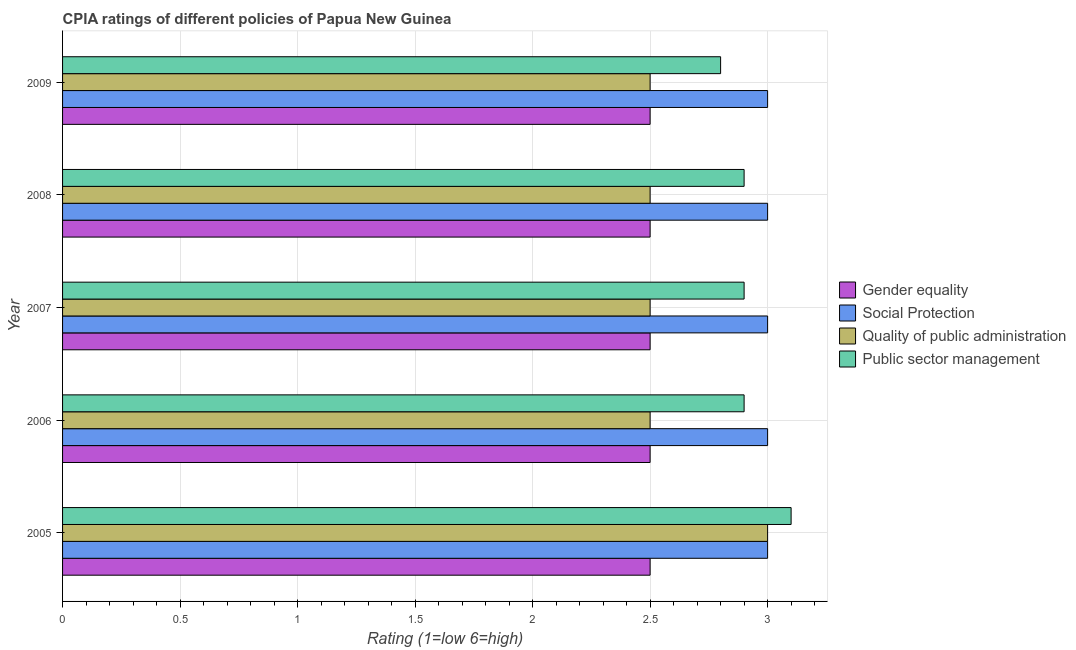How many different coloured bars are there?
Make the answer very short. 4. How many groups of bars are there?
Your response must be concise. 5. How many bars are there on the 1st tick from the bottom?
Keep it short and to the point. 4. What is the cpia rating of gender equality in 2008?
Offer a terse response. 2.5. Across all years, what is the maximum cpia rating of gender equality?
Ensure brevity in your answer.  2.5. Across all years, what is the minimum cpia rating of public sector management?
Your answer should be very brief. 2.8. In which year was the cpia rating of public sector management maximum?
Provide a succinct answer. 2005. What is the total cpia rating of public sector management in the graph?
Offer a very short reply. 14.6. What is the difference between the cpia rating of public sector management in 2007 and the cpia rating of quality of public administration in 2006?
Give a very brief answer. 0.4. What is the ratio of the cpia rating of public sector management in 2005 to that in 2008?
Your response must be concise. 1.07. What is the difference between the highest and the lowest cpia rating of social protection?
Keep it short and to the point. 0. What does the 3rd bar from the top in 2005 represents?
Give a very brief answer. Social Protection. What does the 3rd bar from the bottom in 2007 represents?
Ensure brevity in your answer.  Quality of public administration. Is it the case that in every year, the sum of the cpia rating of gender equality and cpia rating of social protection is greater than the cpia rating of quality of public administration?
Ensure brevity in your answer.  Yes. Are all the bars in the graph horizontal?
Offer a very short reply. Yes. How many years are there in the graph?
Offer a terse response. 5. What is the difference between two consecutive major ticks on the X-axis?
Provide a succinct answer. 0.5. Does the graph contain grids?
Give a very brief answer. Yes. How many legend labels are there?
Ensure brevity in your answer.  4. What is the title of the graph?
Your response must be concise. CPIA ratings of different policies of Papua New Guinea. Does "Social Awareness" appear as one of the legend labels in the graph?
Your response must be concise. No. What is the label or title of the Y-axis?
Your answer should be very brief. Year. What is the Rating (1=low 6=high) in Gender equality in 2005?
Make the answer very short. 2.5. What is the Rating (1=low 6=high) of Social Protection in 2005?
Your response must be concise. 3. What is the Rating (1=low 6=high) of Quality of public administration in 2005?
Keep it short and to the point. 3. What is the Rating (1=low 6=high) of Public sector management in 2005?
Offer a terse response. 3.1. What is the Rating (1=low 6=high) in Social Protection in 2006?
Your answer should be very brief. 3. What is the Rating (1=low 6=high) of Public sector management in 2006?
Offer a terse response. 2.9. What is the Rating (1=low 6=high) of Public sector management in 2007?
Offer a very short reply. 2.9. What is the Rating (1=low 6=high) in Gender equality in 2008?
Provide a succinct answer. 2.5. What is the Rating (1=low 6=high) in Social Protection in 2008?
Make the answer very short. 3. What is the Rating (1=low 6=high) of Gender equality in 2009?
Your response must be concise. 2.5. What is the Rating (1=low 6=high) of Public sector management in 2009?
Provide a short and direct response. 2.8. Across all years, what is the maximum Rating (1=low 6=high) in Public sector management?
Your answer should be compact. 3.1. Across all years, what is the minimum Rating (1=low 6=high) in Gender equality?
Provide a succinct answer. 2.5. Across all years, what is the minimum Rating (1=low 6=high) of Social Protection?
Your response must be concise. 3. What is the total Rating (1=low 6=high) of Gender equality in the graph?
Make the answer very short. 12.5. What is the total Rating (1=low 6=high) of Quality of public administration in the graph?
Give a very brief answer. 13. What is the difference between the Rating (1=low 6=high) in Social Protection in 2005 and that in 2006?
Provide a short and direct response. 0. What is the difference between the Rating (1=low 6=high) in Quality of public administration in 2005 and that in 2006?
Your answer should be very brief. 0.5. What is the difference between the Rating (1=low 6=high) of Public sector management in 2005 and that in 2006?
Ensure brevity in your answer.  0.2. What is the difference between the Rating (1=low 6=high) in Social Protection in 2005 and that in 2007?
Your answer should be compact. 0. What is the difference between the Rating (1=low 6=high) in Quality of public administration in 2005 and that in 2007?
Your answer should be compact. 0.5. What is the difference between the Rating (1=low 6=high) of Social Protection in 2005 and that in 2008?
Provide a short and direct response. 0. What is the difference between the Rating (1=low 6=high) of Quality of public administration in 2005 and that in 2008?
Give a very brief answer. 0.5. What is the difference between the Rating (1=low 6=high) in Public sector management in 2005 and that in 2008?
Your answer should be very brief. 0.2. What is the difference between the Rating (1=low 6=high) in Gender equality in 2005 and that in 2009?
Offer a terse response. 0. What is the difference between the Rating (1=low 6=high) in Social Protection in 2005 and that in 2009?
Your answer should be compact. 0. What is the difference between the Rating (1=low 6=high) in Quality of public administration in 2005 and that in 2009?
Provide a short and direct response. 0.5. What is the difference between the Rating (1=low 6=high) in Quality of public administration in 2006 and that in 2008?
Give a very brief answer. 0. What is the difference between the Rating (1=low 6=high) of Gender equality in 2006 and that in 2009?
Your answer should be compact. 0. What is the difference between the Rating (1=low 6=high) in Social Protection in 2006 and that in 2009?
Keep it short and to the point. 0. What is the difference between the Rating (1=low 6=high) of Gender equality in 2007 and that in 2008?
Your answer should be compact. 0. What is the difference between the Rating (1=low 6=high) in Quality of public administration in 2007 and that in 2008?
Offer a terse response. 0. What is the difference between the Rating (1=low 6=high) of Quality of public administration in 2007 and that in 2009?
Your response must be concise. 0. What is the difference between the Rating (1=low 6=high) in Public sector management in 2007 and that in 2009?
Your answer should be very brief. 0.1. What is the difference between the Rating (1=low 6=high) of Quality of public administration in 2008 and that in 2009?
Your answer should be compact. 0. What is the difference between the Rating (1=low 6=high) in Public sector management in 2008 and that in 2009?
Offer a terse response. 0.1. What is the difference between the Rating (1=low 6=high) in Social Protection in 2005 and the Rating (1=low 6=high) in Quality of public administration in 2006?
Offer a very short reply. 0.5. What is the difference between the Rating (1=low 6=high) of Social Protection in 2005 and the Rating (1=low 6=high) of Public sector management in 2006?
Your answer should be compact. 0.1. What is the difference between the Rating (1=low 6=high) in Quality of public administration in 2005 and the Rating (1=low 6=high) in Public sector management in 2006?
Provide a short and direct response. 0.1. What is the difference between the Rating (1=low 6=high) in Gender equality in 2005 and the Rating (1=low 6=high) in Social Protection in 2007?
Give a very brief answer. -0.5. What is the difference between the Rating (1=low 6=high) in Gender equality in 2005 and the Rating (1=low 6=high) in Social Protection in 2008?
Give a very brief answer. -0.5. What is the difference between the Rating (1=low 6=high) of Gender equality in 2005 and the Rating (1=low 6=high) of Quality of public administration in 2008?
Give a very brief answer. 0. What is the difference between the Rating (1=low 6=high) in Gender equality in 2005 and the Rating (1=low 6=high) in Public sector management in 2008?
Keep it short and to the point. -0.4. What is the difference between the Rating (1=low 6=high) of Social Protection in 2005 and the Rating (1=low 6=high) of Public sector management in 2009?
Your answer should be very brief. 0.2. What is the difference between the Rating (1=low 6=high) of Social Protection in 2006 and the Rating (1=low 6=high) of Quality of public administration in 2007?
Make the answer very short. 0.5. What is the difference between the Rating (1=low 6=high) of Quality of public administration in 2006 and the Rating (1=low 6=high) of Public sector management in 2007?
Your response must be concise. -0.4. What is the difference between the Rating (1=low 6=high) of Gender equality in 2006 and the Rating (1=low 6=high) of Social Protection in 2008?
Make the answer very short. -0.5. What is the difference between the Rating (1=low 6=high) in Social Protection in 2006 and the Rating (1=low 6=high) in Public sector management in 2008?
Give a very brief answer. 0.1. What is the difference between the Rating (1=low 6=high) of Quality of public administration in 2006 and the Rating (1=low 6=high) of Public sector management in 2008?
Your answer should be very brief. -0.4. What is the difference between the Rating (1=low 6=high) in Gender equality in 2006 and the Rating (1=low 6=high) in Quality of public administration in 2009?
Ensure brevity in your answer.  0. What is the difference between the Rating (1=low 6=high) in Gender equality in 2007 and the Rating (1=low 6=high) in Social Protection in 2008?
Ensure brevity in your answer.  -0.5. What is the difference between the Rating (1=low 6=high) in Gender equality in 2007 and the Rating (1=low 6=high) in Public sector management in 2008?
Offer a terse response. -0.4. What is the difference between the Rating (1=low 6=high) of Social Protection in 2007 and the Rating (1=low 6=high) of Quality of public administration in 2008?
Your answer should be very brief. 0.5. What is the difference between the Rating (1=low 6=high) in Social Protection in 2007 and the Rating (1=low 6=high) in Public sector management in 2008?
Your answer should be very brief. 0.1. What is the difference between the Rating (1=low 6=high) in Quality of public administration in 2007 and the Rating (1=low 6=high) in Public sector management in 2008?
Ensure brevity in your answer.  -0.4. What is the difference between the Rating (1=low 6=high) in Gender equality in 2007 and the Rating (1=low 6=high) in Public sector management in 2009?
Ensure brevity in your answer.  -0.3. What is the difference between the Rating (1=low 6=high) of Social Protection in 2007 and the Rating (1=low 6=high) of Quality of public administration in 2009?
Your response must be concise. 0.5. What is the difference between the Rating (1=low 6=high) in Social Protection in 2007 and the Rating (1=low 6=high) in Public sector management in 2009?
Your answer should be very brief. 0.2. What is the difference between the Rating (1=low 6=high) of Gender equality in 2008 and the Rating (1=low 6=high) of Public sector management in 2009?
Provide a short and direct response. -0.3. What is the difference between the Rating (1=low 6=high) of Quality of public administration in 2008 and the Rating (1=low 6=high) of Public sector management in 2009?
Keep it short and to the point. -0.3. What is the average Rating (1=low 6=high) of Quality of public administration per year?
Provide a short and direct response. 2.6. What is the average Rating (1=low 6=high) in Public sector management per year?
Ensure brevity in your answer.  2.92. In the year 2005, what is the difference between the Rating (1=low 6=high) in Social Protection and Rating (1=low 6=high) in Public sector management?
Offer a terse response. -0.1. In the year 2005, what is the difference between the Rating (1=low 6=high) of Quality of public administration and Rating (1=low 6=high) of Public sector management?
Provide a short and direct response. -0.1. In the year 2006, what is the difference between the Rating (1=low 6=high) in Gender equality and Rating (1=low 6=high) in Public sector management?
Your response must be concise. -0.4. In the year 2006, what is the difference between the Rating (1=low 6=high) in Social Protection and Rating (1=low 6=high) in Quality of public administration?
Give a very brief answer. 0.5. In the year 2007, what is the difference between the Rating (1=low 6=high) of Social Protection and Rating (1=low 6=high) of Public sector management?
Offer a very short reply. 0.1. In the year 2007, what is the difference between the Rating (1=low 6=high) of Quality of public administration and Rating (1=low 6=high) of Public sector management?
Offer a terse response. -0.4. In the year 2008, what is the difference between the Rating (1=low 6=high) of Gender equality and Rating (1=low 6=high) of Public sector management?
Your answer should be very brief. -0.4. In the year 2008, what is the difference between the Rating (1=low 6=high) in Social Protection and Rating (1=low 6=high) in Quality of public administration?
Make the answer very short. 0.5. In the year 2008, what is the difference between the Rating (1=low 6=high) in Social Protection and Rating (1=low 6=high) in Public sector management?
Give a very brief answer. 0.1. In the year 2009, what is the difference between the Rating (1=low 6=high) of Gender equality and Rating (1=low 6=high) of Social Protection?
Give a very brief answer. -0.5. In the year 2009, what is the difference between the Rating (1=low 6=high) of Gender equality and Rating (1=low 6=high) of Public sector management?
Give a very brief answer. -0.3. In the year 2009, what is the difference between the Rating (1=low 6=high) in Social Protection and Rating (1=low 6=high) in Quality of public administration?
Give a very brief answer. 0.5. In the year 2009, what is the difference between the Rating (1=low 6=high) in Social Protection and Rating (1=low 6=high) in Public sector management?
Offer a terse response. 0.2. In the year 2009, what is the difference between the Rating (1=low 6=high) of Quality of public administration and Rating (1=low 6=high) of Public sector management?
Offer a terse response. -0.3. What is the ratio of the Rating (1=low 6=high) in Public sector management in 2005 to that in 2006?
Provide a short and direct response. 1.07. What is the ratio of the Rating (1=low 6=high) in Social Protection in 2005 to that in 2007?
Provide a succinct answer. 1. What is the ratio of the Rating (1=low 6=high) of Public sector management in 2005 to that in 2007?
Your response must be concise. 1.07. What is the ratio of the Rating (1=low 6=high) in Social Protection in 2005 to that in 2008?
Ensure brevity in your answer.  1. What is the ratio of the Rating (1=low 6=high) of Public sector management in 2005 to that in 2008?
Make the answer very short. 1.07. What is the ratio of the Rating (1=low 6=high) in Gender equality in 2005 to that in 2009?
Make the answer very short. 1. What is the ratio of the Rating (1=low 6=high) of Social Protection in 2005 to that in 2009?
Make the answer very short. 1. What is the ratio of the Rating (1=low 6=high) of Public sector management in 2005 to that in 2009?
Make the answer very short. 1.11. What is the ratio of the Rating (1=low 6=high) of Quality of public administration in 2006 to that in 2007?
Offer a terse response. 1. What is the ratio of the Rating (1=low 6=high) of Social Protection in 2006 to that in 2008?
Your answer should be compact. 1. What is the ratio of the Rating (1=low 6=high) in Public sector management in 2006 to that in 2008?
Provide a short and direct response. 1. What is the ratio of the Rating (1=low 6=high) in Social Protection in 2006 to that in 2009?
Give a very brief answer. 1. What is the ratio of the Rating (1=low 6=high) of Public sector management in 2006 to that in 2009?
Your answer should be compact. 1.04. What is the ratio of the Rating (1=low 6=high) of Social Protection in 2007 to that in 2008?
Provide a succinct answer. 1. What is the ratio of the Rating (1=low 6=high) of Gender equality in 2007 to that in 2009?
Ensure brevity in your answer.  1. What is the ratio of the Rating (1=low 6=high) of Social Protection in 2007 to that in 2009?
Provide a succinct answer. 1. What is the ratio of the Rating (1=low 6=high) of Quality of public administration in 2007 to that in 2009?
Make the answer very short. 1. What is the ratio of the Rating (1=low 6=high) of Public sector management in 2007 to that in 2009?
Your answer should be very brief. 1.04. What is the ratio of the Rating (1=low 6=high) in Quality of public administration in 2008 to that in 2009?
Offer a very short reply. 1. What is the ratio of the Rating (1=low 6=high) of Public sector management in 2008 to that in 2009?
Your response must be concise. 1.04. What is the difference between the highest and the second highest Rating (1=low 6=high) of Quality of public administration?
Provide a succinct answer. 0.5. What is the difference between the highest and the lowest Rating (1=low 6=high) of Quality of public administration?
Your answer should be compact. 0.5. What is the difference between the highest and the lowest Rating (1=low 6=high) of Public sector management?
Keep it short and to the point. 0.3. 